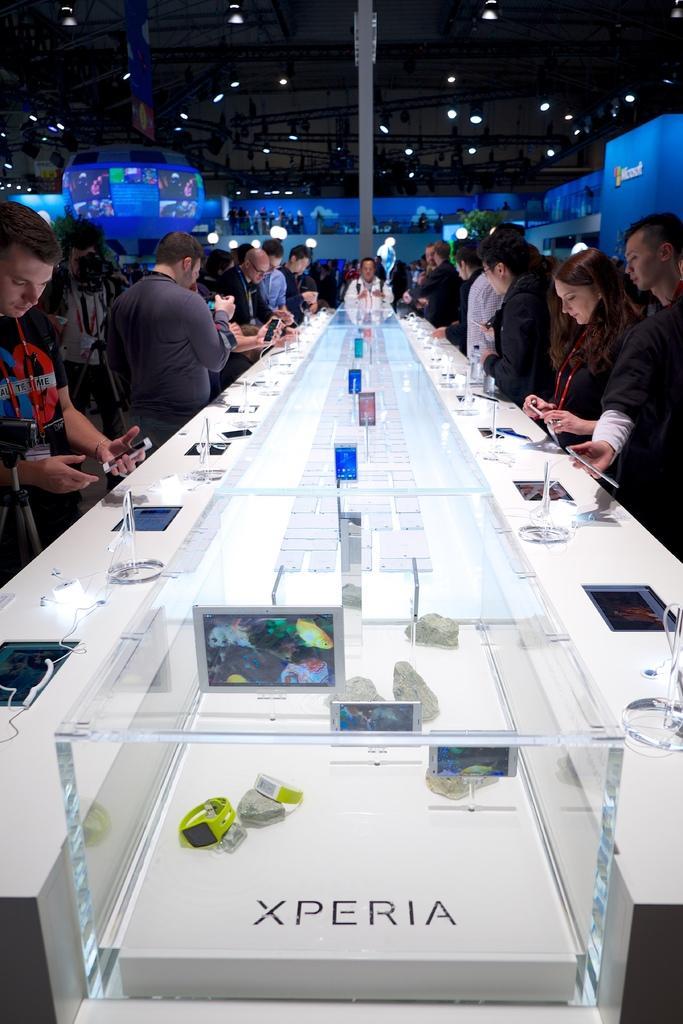Describe this image in one or two sentences. There are so many people standing in front of desk and watching the mobiles. There are different types of mobiles here. There is a sony tab,mobiles on the glass. At the top we have here is a ceiling. There is lights at the top. There is screen at the top. A man is wearing a id card and watching the mobile. 